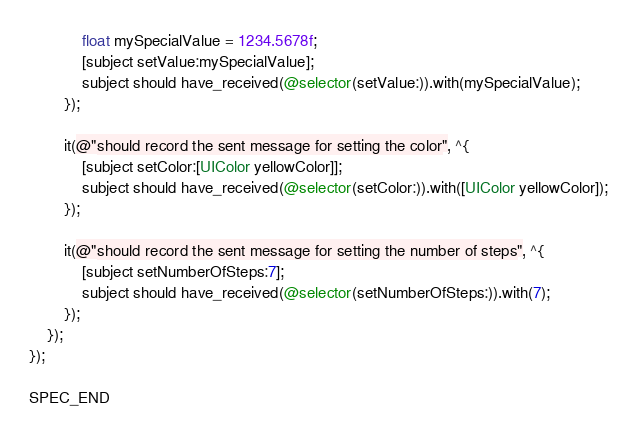<code> <loc_0><loc_0><loc_500><loc_500><_ObjectiveC_>            float mySpecialValue = 1234.5678f;
            [subject setValue:mySpecialValue];
            subject should have_received(@selector(setValue:)).with(mySpecialValue);
        });

        it(@"should record the sent message for setting the color", ^{
            [subject setColor:[UIColor yellowColor]];
            subject should have_received(@selector(setColor:)).with([UIColor yellowColor]);
        });

        it(@"should record the sent message for setting the number of steps", ^{
            [subject setNumberOfSteps:7];
            subject should have_received(@selector(setNumberOfSteps:)).with(7);
        });
    });
});

SPEC_END
</code> 